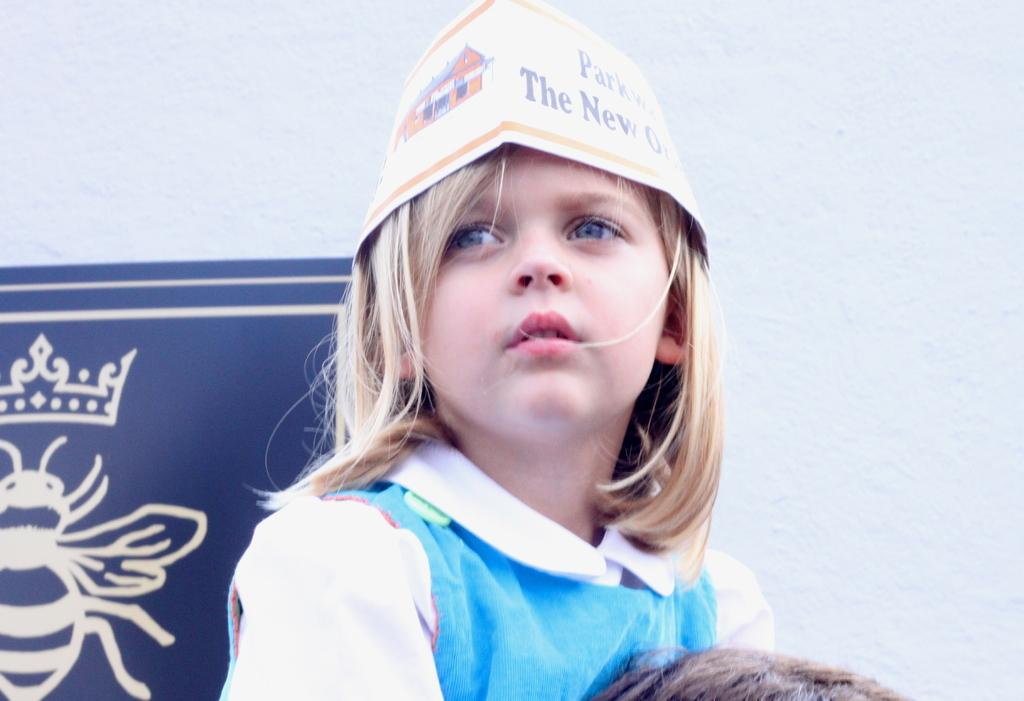<image>
Share a concise interpretation of the image provided. A young girl wears a paper hat with a partially visible phrase on it which reads "The New". 